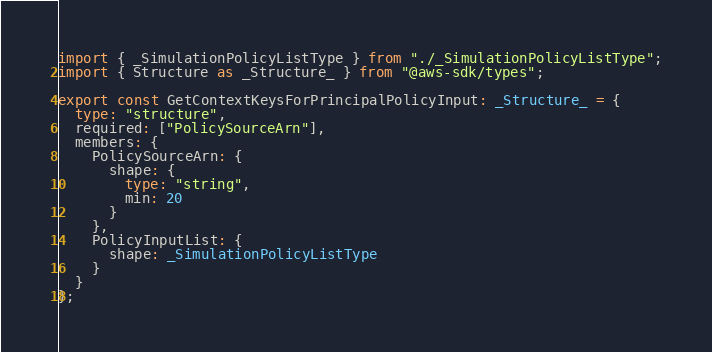Convert code to text. <code><loc_0><loc_0><loc_500><loc_500><_TypeScript_>import { _SimulationPolicyListType } from "./_SimulationPolicyListType";
import { Structure as _Structure_ } from "@aws-sdk/types";

export const GetContextKeysForPrincipalPolicyInput: _Structure_ = {
  type: "structure",
  required: ["PolicySourceArn"],
  members: {
    PolicySourceArn: {
      shape: {
        type: "string",
        min: 20
      }
    },
    PolicyInputList: {
      shape: _SimulationPolicyListType
    }
  }
};
</code> 